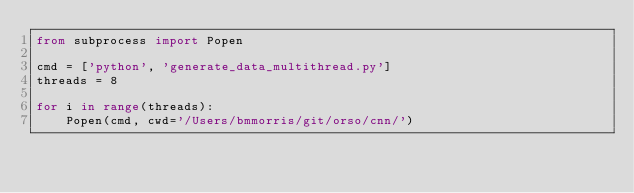<code> <loc_0><loc_0><loc_500><loc_500><_Python_>from subprocess import Popen 

cmd = ['python', 'generate_data_multithread.py']
threads = 8

for i in range(threads):
    Popen(cmd, cwd='/Users/bmmorris/git/orso/cnn/')</code> 